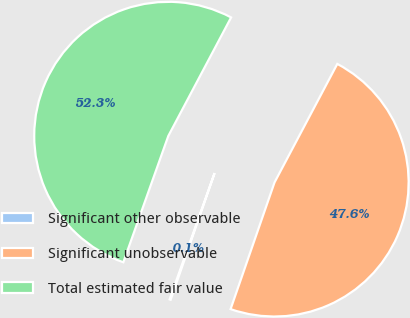Convert chart. <chart><loc_0><loc_0><loc_500><loc_500><pie_chart><fcel>Significant other observable<fcel>Significant unobservable<fcel>Total estimated fair value<nl><fcel>0.13%<fcel>47.56%<fcel>52.31%<nl></chart> 